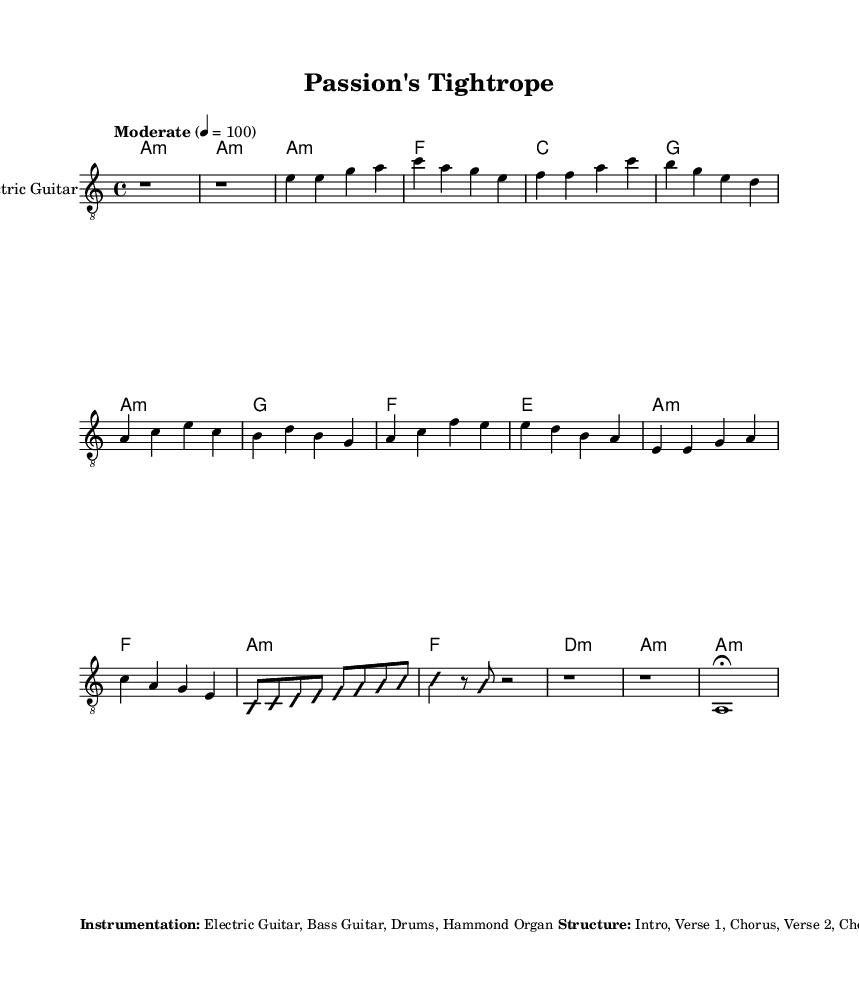What is the key signature of this music? The key signature is indicated in the global section. It shows the note "a" followed by "minor," meaning the key signature is A minor, which has no sharps or flats.
Answer: A minor What is the time signature of this piece? The time signature is stated in the global section. Here it is represented by "4/4," which indicates there are four beats per measure, and the quarter note receives one beat.
Answer: 4/4 What is the tempo marking for this music? The tempo marking is found in the global section. It specifies "Moderate" with a metronomic marking of 4 = 100, indicating the intended speed of the piece.
Answer: Moderate, 4 = 100 How many sections does the structure of the music have? The structure is detailed in the markup section which gives the parts as: Intro, Verse 1, Chorus, Verse 2, Chorus, Guitar Solo, Bridge, Chorus, Outro. Counting these gives us a total of eight sections.
Answer: 8 What describes the overall theme of the music? The theme is outlined in the markup section, which clearly states it relates to balancing work demands with musical passion, highlighting struggle and determination.
Answer: Balancing work and passion What is the main instrument featured in this piece? The instrumentation is described in the markup section, clearly listing "Electric Guitar" as the primary instrument used for this piece, along with other supporting instruments.
Answer: Electric Guitar What dynamic marking is indicated for the Outro section? The dynamic marking for the Outro is specified in the markup section, which denotes "ff," indicating the section should be played fortissimo, or very loudly.
Answer: ff 